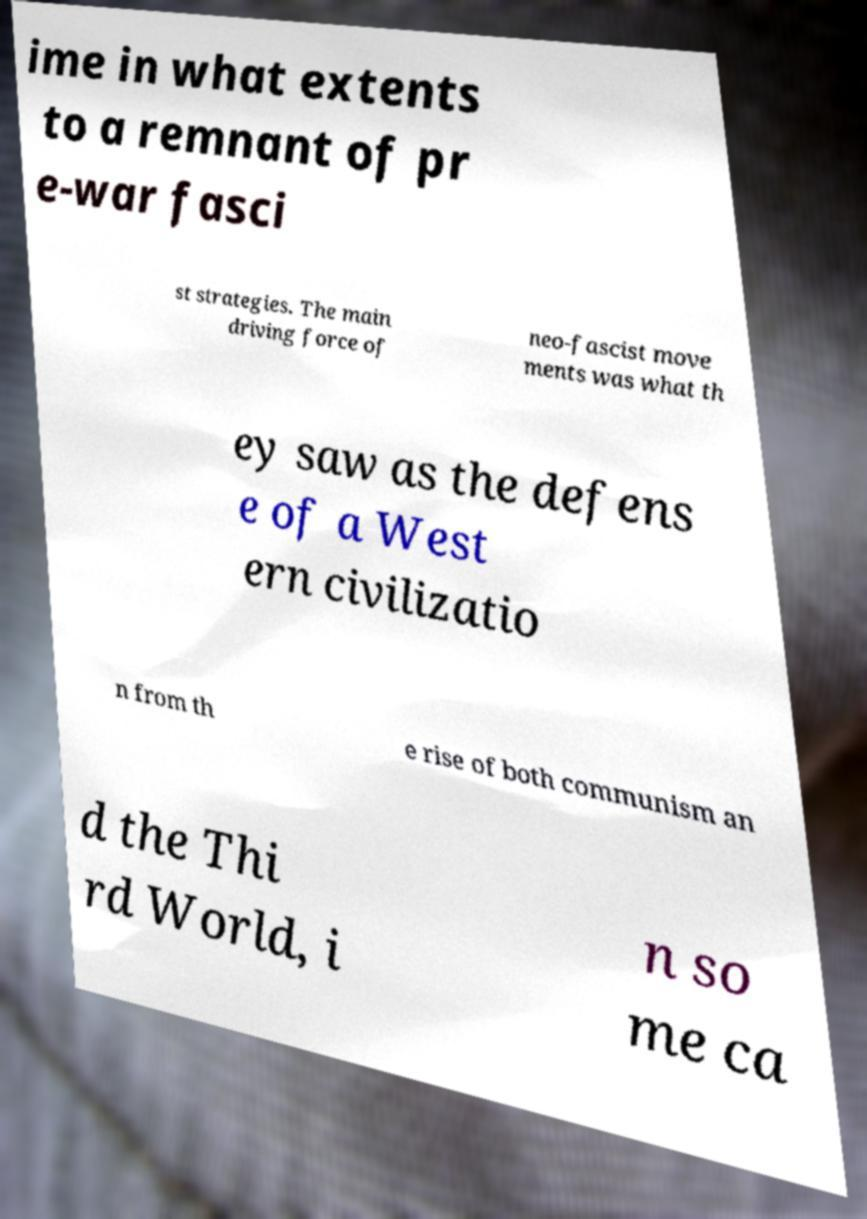Could you extract and type out the text from this image? ime in what extents to a remnant of pr e-war fasci st strategies. The main driving force of neo-fascist move ments was what th ey saw as the defens e of a West ern civilizatio n from th e rise of both communism an d the Thi rd World, i n so me ca 